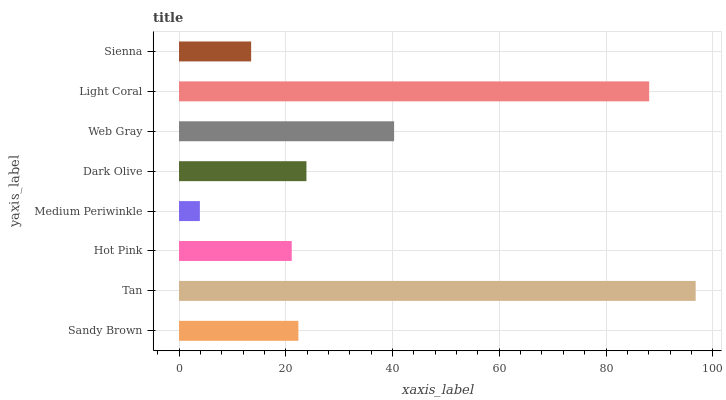Is Medium Periwinkle the minimum?
Answer yes or no. Yes. Is Tan the maximum?
Answer yes or no. Yes. Is Hot Pink the minimum?
Answer yes or no. No. Is Hot Pink the maximum?
Answer yes or no. No. Is Tan greater than Hot Pink?
Answer yes or no. Yes. Is Hot Pink less than Tan?
Answer yes or no. Yes. Is Hot Pink greater than Tan?
Answer yes or no. No. Is Tan less than Hot Pink?
Answer yes or no. No. Is Dark Olive the high median?
Answer yes or no. Yes. Is Sandy Brown the low median?
Answer yes or no. Yes. Is Light Coral the high median?
Answer yes or no. No. Is Dark Olive the low median?
Answer yes or no. No. 